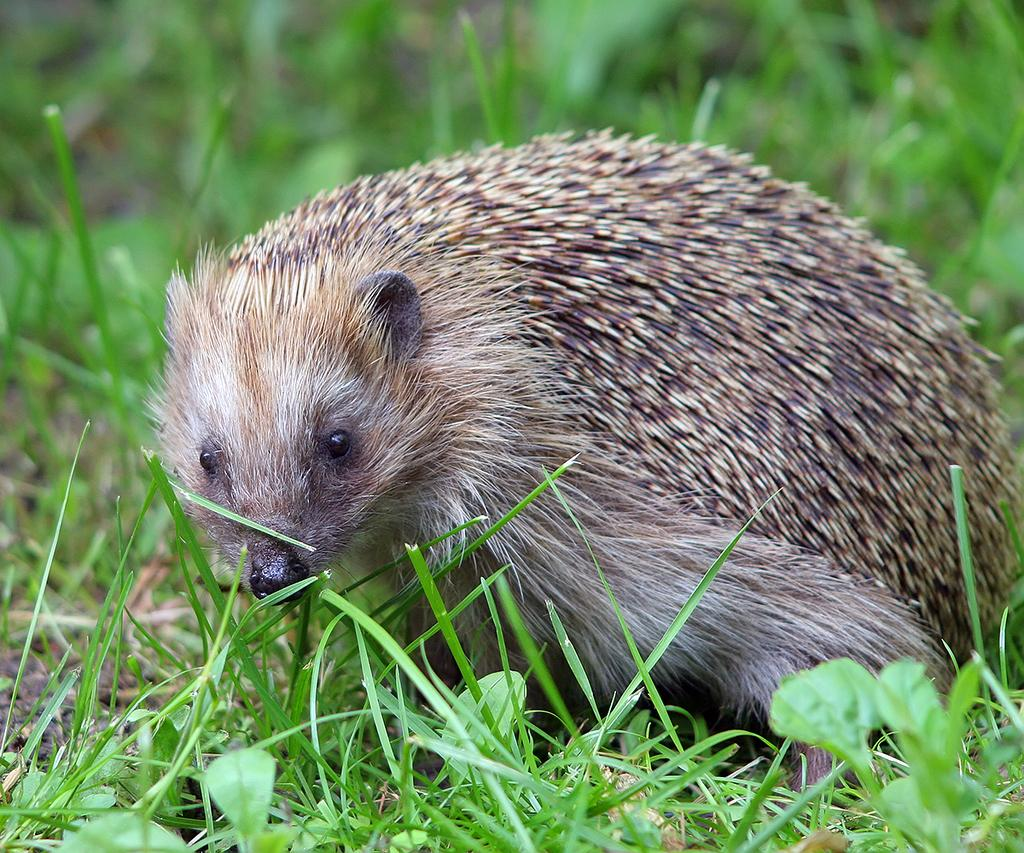What is present on the ground in the image? There are plants on the ground in the image. What type of living creature can be seen in the image? There is an animal in the image. How would you describe the background of the image? The background is blurred and green. What type of pain is the animal experiencing in the image? There is no indication of pain in the image; the animal appears to be in its natural environment. What is the name of the animal's son in the image? There is no son present in the image, as it only features an animal and plants. 